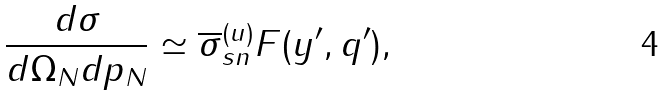<formula> <loc_0><loc_0><loc_500><loc_500>\frac { d \sigma } { d \Omega _ { N } d p _ { N } } \simeq \overline { \sigma } _ { s n } ^ { ( u ) } F ( y ^ { \prime } , q ^ { \prime } ) ,</formula> 